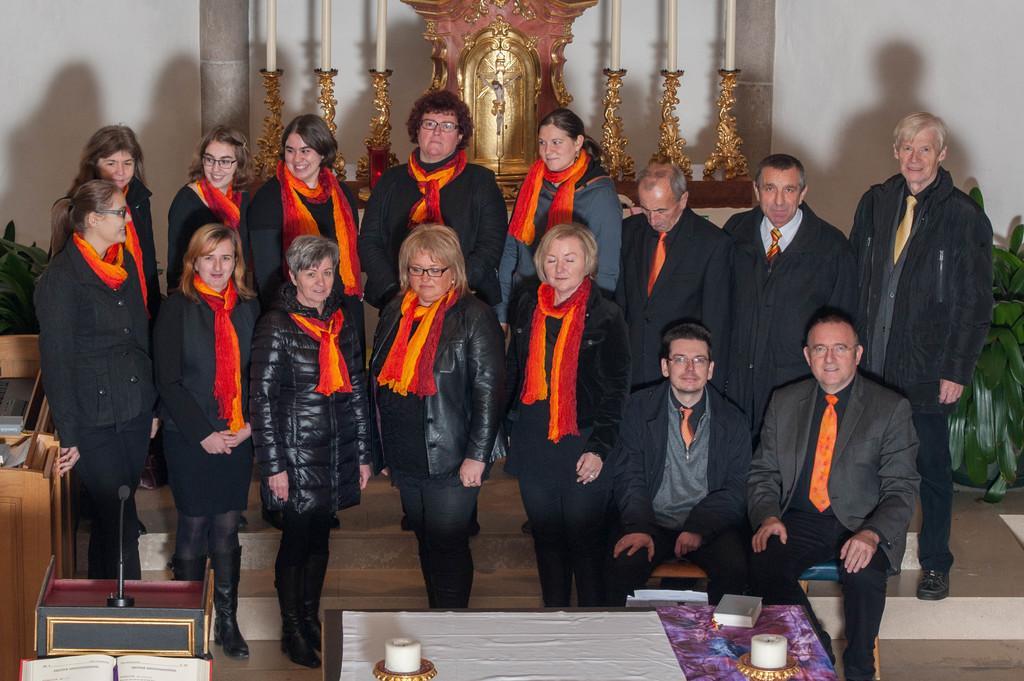Could you give a brief overview of what you see in this image? In this picture I can see there are a group of people and they are wearing orange color scarves and they are wearing black color coats and blazers and in the backdrop I can see there are candles and candle holders and there is a wall. 